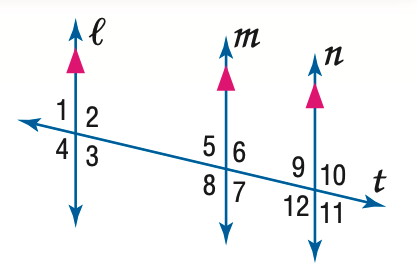Answer the mathemtical geometry problem and directly provide the correct option letter.
Question: In the figure, m \angle 9 = 75. Find the measure of \angle 3.
Choices: A: 75 B: 85 C: 95 D: 105 A 